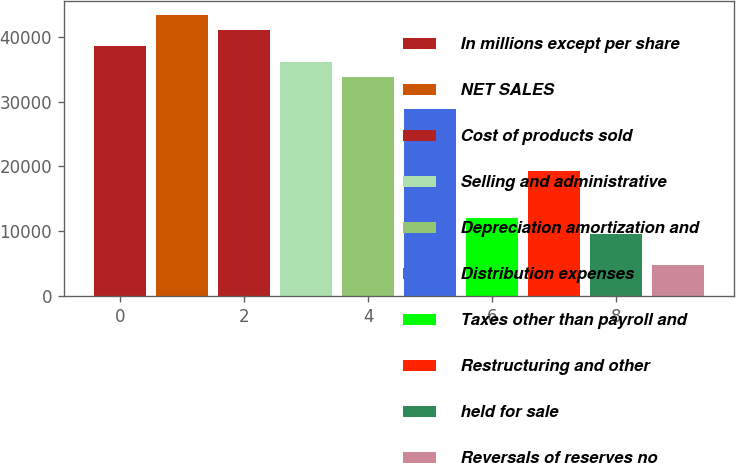<chart> <loc_0><loc_0><loc_500><loc_500><bar_chart><fcel>In millions except per share<fcel>NET SALES<fcel>Cost of products sold<fcel>Selling and administrative<fcel>Depreciation amortization and<fcel>Distribution expenses<fcel>Taxes other than payroll and<fcel>Restructuring and other<fcel>held for sale<fcel>Reversals of reserves no<nl><fcel>38554.1<fcel>43373.1<fcel>40963.6<fcel>36144.6<fcel>33735.1<fcel>28916<fcel>12049.4<fcel>19277.9<fcel>9639.85<fcel>4820.81<nl></chart> 